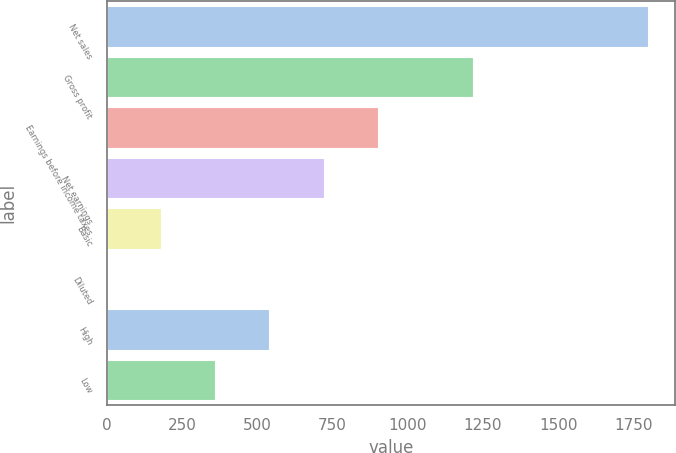Convert chart. <chart><loc_0><loc_0><loc_500><loc_500><bar_chart><fcel>Net sales<fcel>Gross profit<fcel>Earnings before income taxes<fcel>Net earnings<fcel>Basic<fcel>Diluted<fcel>High<fcel>Low<nl><fcel>1799.1<fcel>1217.7<fcel>899.95<fcel>720.12<fcel>180.63<fcel>0.8<fcel>540.29<fcel>360.46<nl></chart> 